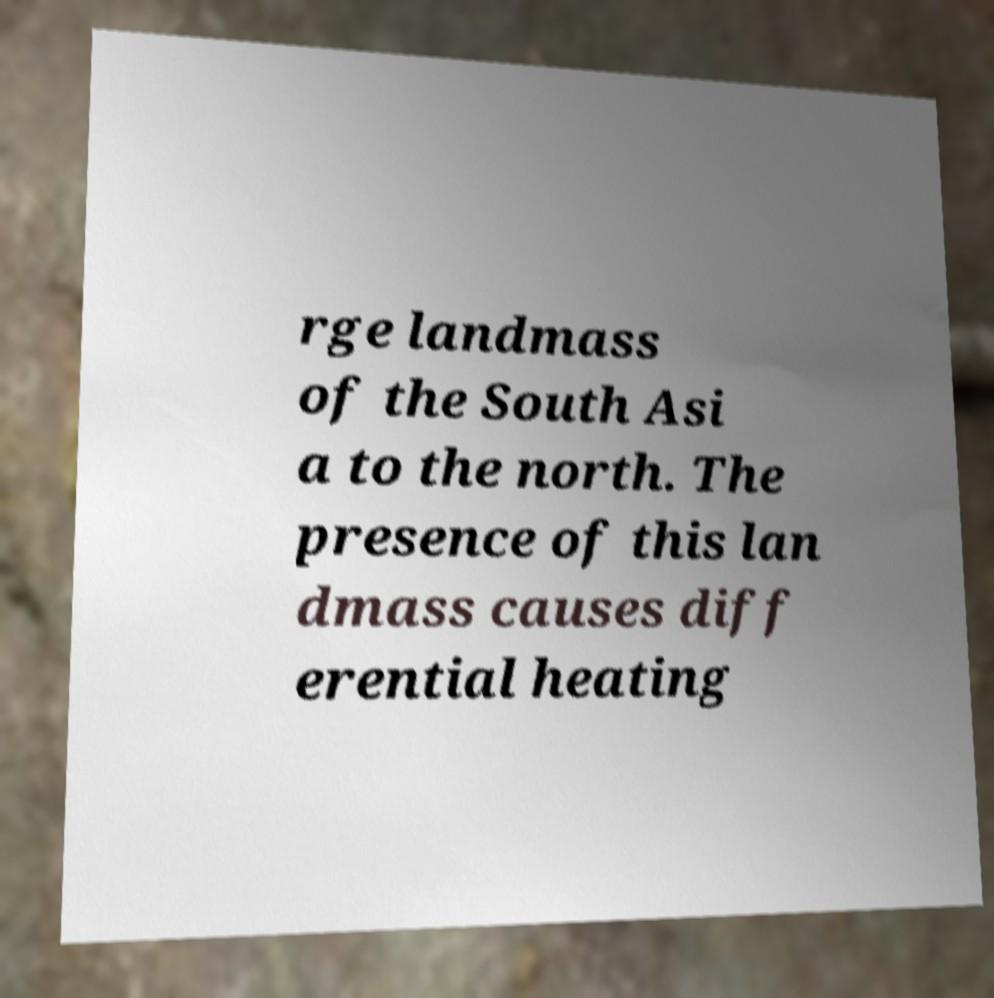Please read and relay the text visible in this image. What does it say? rge landmass of the South Asi a to the north. The presence of this lan dmass causes diff erential heating 